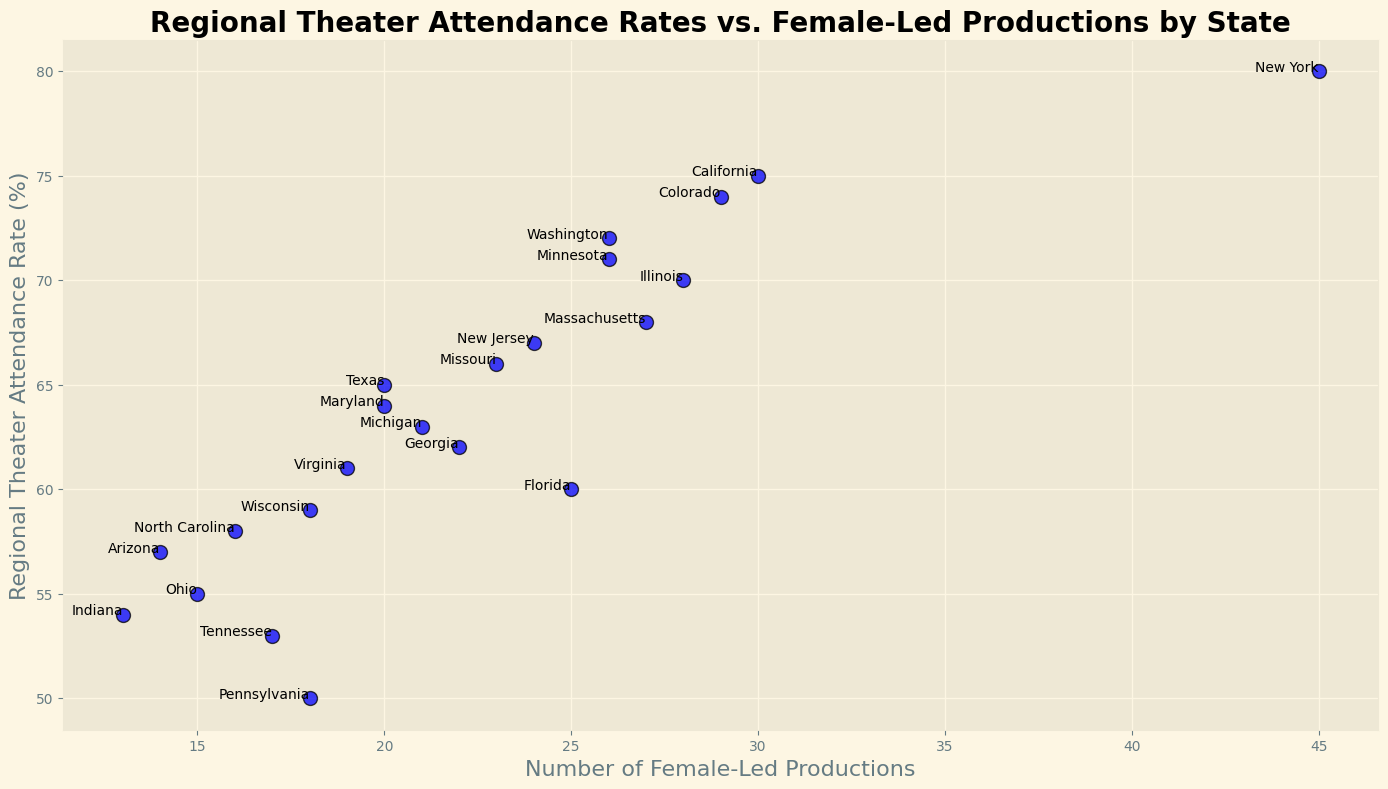What state has the highest regional theater attendance rate? By examining the y-axis, we see that New York has the highest regional theater attendance rate.
Answer: New York Which state has the lowest number of female-led productions? Looking at the x-axis, Indiana has the lowest number of female-led productions.
Answer: Indiana What is the difference in regional theater attendance rates between New York and Florida? New York has an attendance rate of 80%, while Florida has 60%. The difference is 80 - 60.
Answer: 20% Which state has similar numbers of female-led productions but different attendance rates compared to California? Both Illinois and Massachusetts have female-led productions close to California (28 and 27 respectively), but their attendance rates (70% and 68%) differ compared to California's 75%.
Answer: Illinois Are there any states with both high theater attendance rates (over 70%) and a high number of female-led productions (over 25)? New York, California, and Colorado all meet these criteria with attendance rates of 80%, 75%, 74%, and female-led productions of 45, 30, 29 respectively.
Answer: New York, California, Colorado Is there a state with an attendance rate lower than Wisconsin but a higher number of female-led productions? Wisconsin has a rate of 59% and female-led productions of 18. Florida has a lower attendance rate at 60% but a higher number of female-led productions at 25.
Answer: Florida Which state has the exact same number of female-led productions as Ohio but a higher attendance rate? Marylannd has 20 female-led productions, the same as Ohio, but Maryland has a higher attendance rate at 64% compared to Ohio's 55%.
Answer: Maryland What is the sum of female-led productions for the states with attendance rates below 55%? Pennsylvania, Ohio, Tennessee, and Indiana have attendance rates below 55%. Their female-led productions are 18, 15, 17, and 13 respectively. Summing them up: 18 + 15 + 17 + 13 = 63.
Answer: 63 What is the median number of female-led productions? Ordering the female-led productions: 13, 14, 15, 16, 17, 18, 18, 19, 20, 20, 21, 22, 23, 24, 25, 26, 26, 27, 28, 29, 30, 45. The median, being the average of the 11th and 12th values is (21+22)/2 = 21.5.
Answer: 21.5 Is there a positive correlation between the number of female-led productions and regional theater attendance rates? Generally, as the number of female-led productions increases, the regional theater attendance rates tend to increase, indicating a positive correlation.
Answer: Yes 